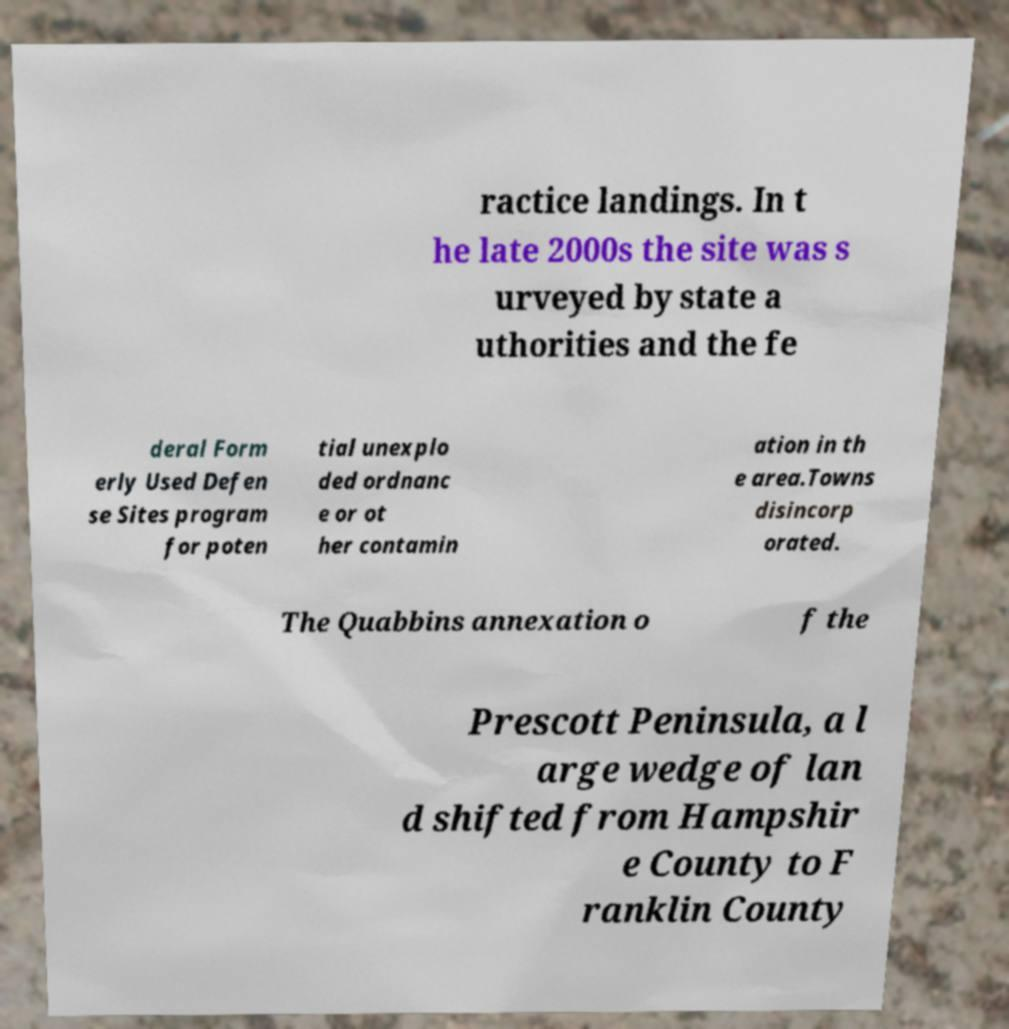Please read and relay the text visible in this image. What does it say? ractice landings. In t he late 2000s the site was s urveyed by state a uthorities and the fe deral Form erly Used Defen se Sites program for poten tial unexplo ded ordnanc e or ot her contamin ation in th e area.Towns disincorp orated. The Quabbins annexation o f the Prescott Peninsula, a l arge wedge of lan d shifted from Hampshir e County to F ranklin County 